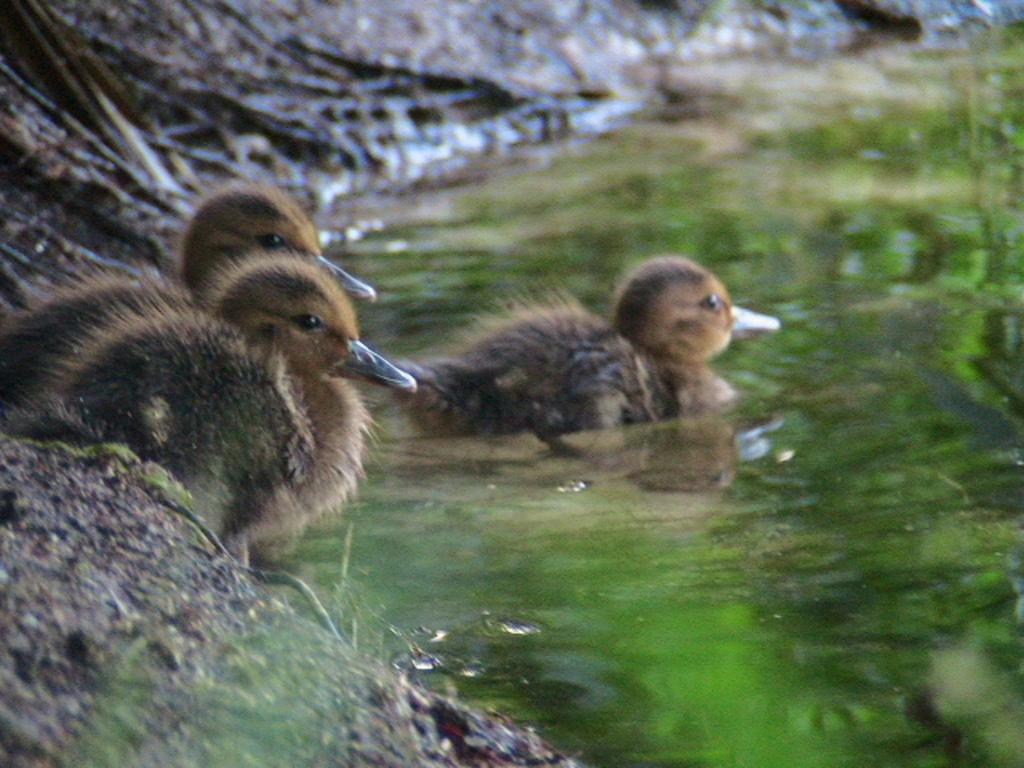What is the primary element in the image? There is water in the image. What type of bird can be seen in the water? A mallard is present in the water. How many additional mallards are visible in the image? There are two additional mallards on the ground in the image. What shape is the pot in the image? There is no pot present in the image. 